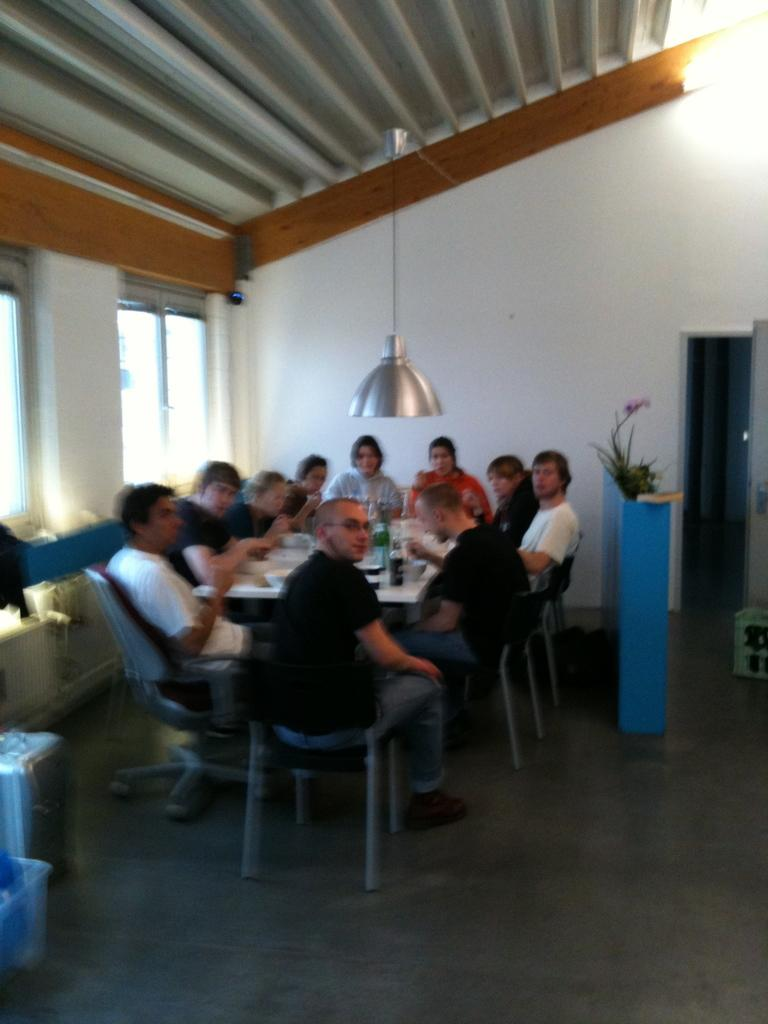What are the people in the image doing? The people in the image are sitting on chairs. How are the chairs arranged in the image? The chairs are arranged around a table. What can be seen hanging from the ceiling in the image? There is a lamp hanging from the ceiling in the image. What type of pail is being used to collect the sleet in the image? There is no pail or sleet present in the image; it features people sitting on chairs around a table with a hanging lamp. How much sugar is visible on the table in the image? There is no sugar visible on the table in the image. 